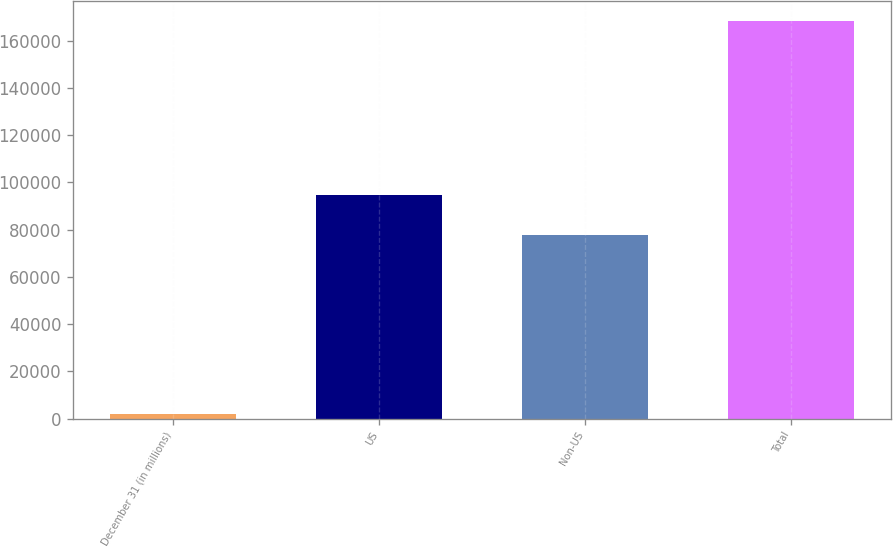Convert chart to OTSL. <chart><loc_0><loc_0><loc_500><loc_500><bar_chart><fcel>December 31 (in millions)<fcel>US<fcel>Non-US<fcel>Total<nl><fcel>2009<fcel>94530<fcel>77887<fcel>168439<nl></chart> 